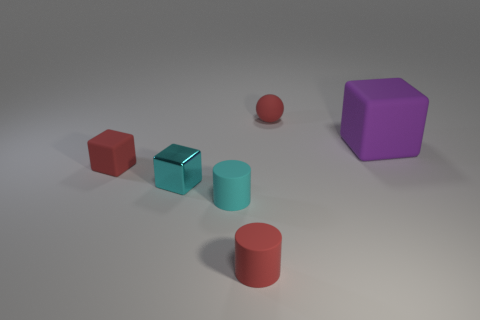Add 2 small matte cubes. How many objects exist? 8 Subtract all cylinders. How many objects are left? 4 Add 3 small purple rubber spheres. How many small purple rubber spheres exist? 3 Subtract 0 brown cylinders. How many objects are left? 6 Subtract all red cubes. Subtract all red rubber things. How many objects are left? 2 Add 4 red spheres. How many red spheres are left? 5 